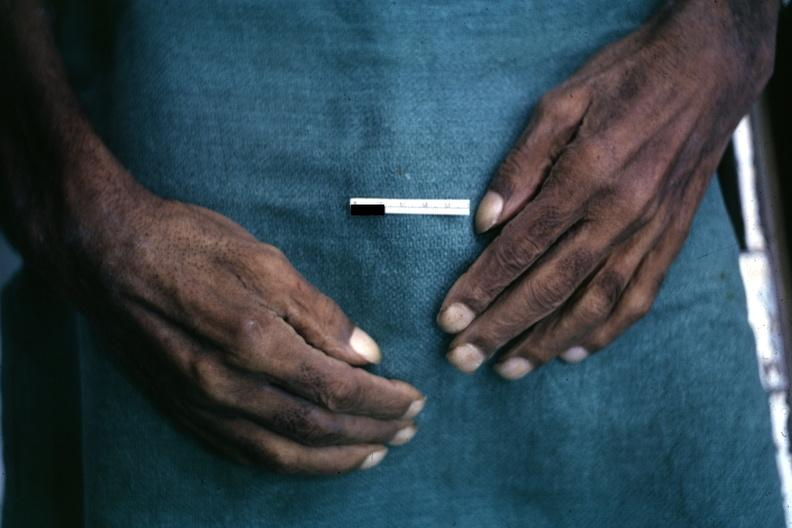does typical tuberculous exudate show obvious lesion?
Answer the question using a single word or phrase. No 